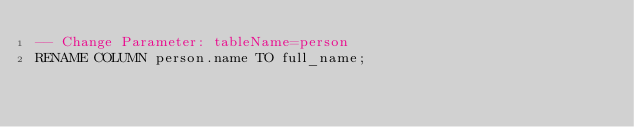Convert code to text. <code><loc_0><loc_0><loc_500><loc_500><_SQL_>-- Change Parameter: tableName=person
RENAME COLUMN person.name TO full_name;
</code> 